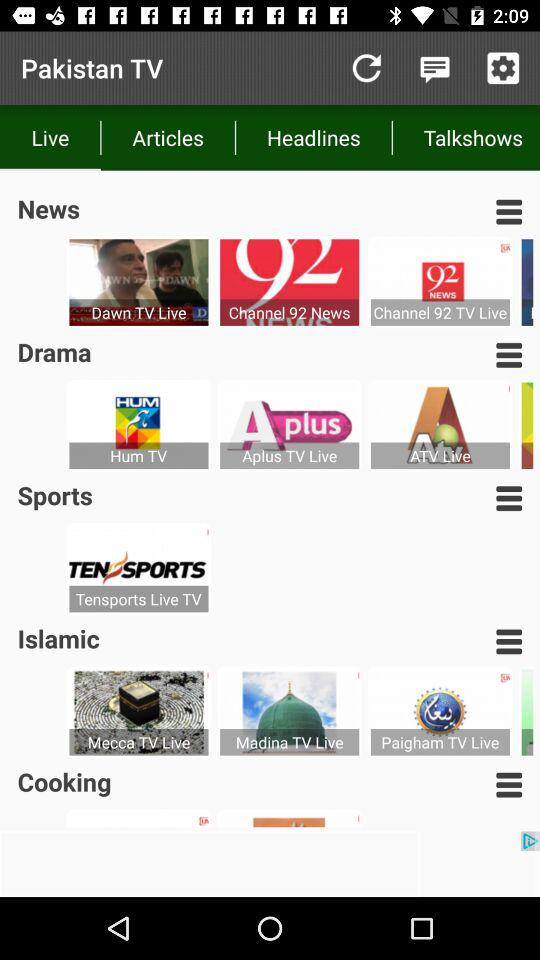What is the name of the sports channel? The name of the sports channel is "Tensports Live TV". 